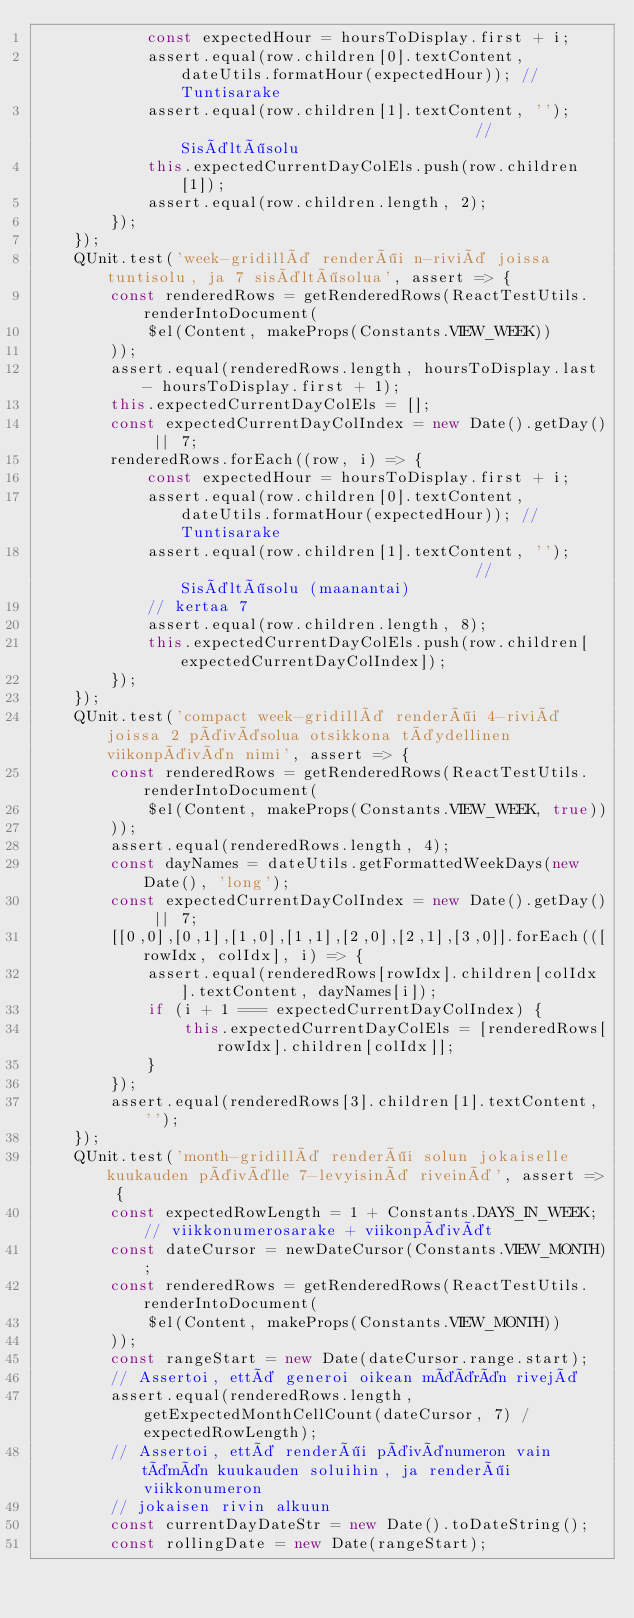Convert code to text. <code><loc_0><loc_0><loc_500><loc_500><_JavaScript_>            const expectedHour = hoursToDisplay.first + i;
            assert.equal(row.children[0].textContent, dateUtils.formatHour(expectedHour)); // Tuntisarake
            assert.equal(row.children[1].textContent, '');                                 // Sisältösolu
            this.expectedCurrentDayColEls.push(row.children[1]);
            assert.equal(row.children.length, 2);
        });
    });
    QUnit.test('week-gridillä renderöi n-riviä joissa tuntisolu, ja 7 sisältösolua', assert => {
        const renderedRows = getRenderedRows(ReactTestUtils.renderIntoDocument(
            $el(Content, makeProps(Constants.VIEW_WEEK))
        ));
        assert.equal(renderedRows.length, hoursToDisplay.last - hoursToDisplay.first + 1);
        this.expectedCurrentDayColEls = [];
        const expectedCurrentDayColIndex = new Date().getDay() || 7;
        renderedRows.forEach((row, i) => {
            const expectedHour = hoursToDisplay.first + i;
            assert.equal(row.children[0].textContent, dateUtils.formatHour(expectedHour)); // Tuntisarake
            assert.equal(row.children[1].textContent, '');                                 // Sisältösolu (maanantai)
            // kertaa 7
            assert.equal(row.children.length, 8);
            this.expectedCurrentDayColEls.push(row.children[expectedCurrentDayColIndex]);
        });
    });
    QUnit.test('compact week-gridillä renderöi 4-riviä joissa 2 päiväsolua otsikkona täydellinen viikonpäivän nimi', assert => {
        const renderedRows = getRenderedRows(ReactTestUtils.renderIntoDocument(
            $el(Content, makeProps(Constants.VIEW_WEEK, true))
        ));
        assert.equal(renderedRows.length, 4);
        const dayNames = dateUtils.getFormattedWeekDays(new Date(), 'long');
        const expectedCurrentDayColIndex = new Date().getDay() || 7;
        [[0,0],[0,1],[1,0],[1,1],[2,0],[2,1],[3,0]].forEach(([rowIdx, colIdx], i) => {
            assert.equal(renderedRows[rowIdx].children[colIdx].textContent, dayNames[i]);
            if (i + 1 === expectedCurrentDayColIndex) {
                this.expectedCurrentDayColEls = [renderedRows[rowIdx].children[colIdx]];
            }
        });
        assert.equal(renderedRows[3].children[1].textContent, '');
    });
    QUnit.test('month-gridillä renderöi solun jokaiselle kuukauden päivälle 7-levyisinä riveinä', assert => {
        const expectedRowLength = 1 + Constants.DAYS_IN_WEEK; // viikkonumerosarake + viikonpäivät
        const dateCursor = newDateCursor(Constants.VIEW_MONTH);
        const renderedRows = getRenderedRows(ReactTestUtils.renderIntoDocument(
            $el(Content, makeProps(Constants.VIEW_MONTH))
        ));
        const rangeStart = new Date(dateCursor.range.start);
        // Assertoi, että generoi oikean määrän rivejä
        assert.equal(renderedRows.length, getExpectedMonthCellCount(dateCursor, 7) / expectedRowLength);
        // Assertoi, että renderöi päivänumeron vain tämän kuukauden soluihin, ja renderöi viikkonumeron
        // jokaisen rivin alkuun
        const currentDayDateStr = new Date().toDateString();
        const rollingDate = new Date(rangeStart);</code> 